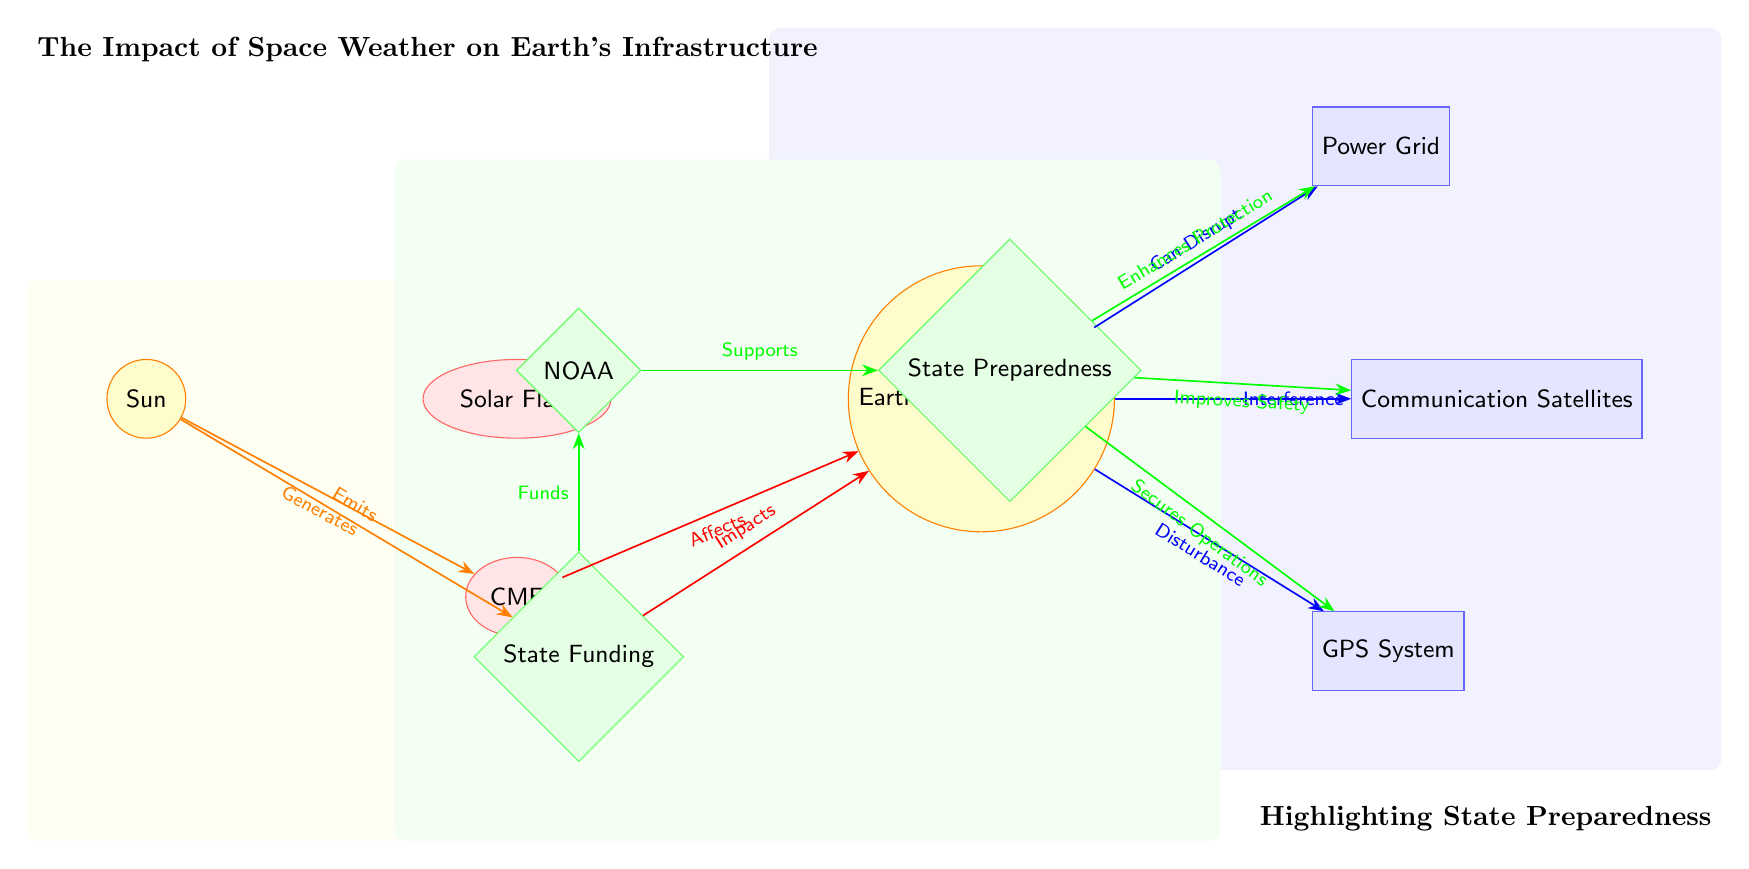What is the primary celestial body shown in the diagram? The diagram identifies the Sun as the primary celestial body, depicted at the top of the structure.
Answer: Sun How many infrastructure elements are represented in the diagram? There are three distinct infrastructure elements: Power Grid, Communication Satellites, and GPS System. This is determined by counting the rectangles colored blue within the infrastructure category.
Answer: 3 What does a Solar Flare impact according to the diagram? The diagram indicates that a Solar Flare impacts Earth's Magnetosphere, which is directly connected by an edge indicating the flow of effect.
Answer: Earth's Magnetosphere Which event is generated by the Sun? According to the diagram, the Sun emits a Solar Flare and generates a Coronal Mass Ejection (CME), both of which are directly shown in relation to the Sun.
Answer: CME What does State Preparedness enhance according to the diagram? The diagram shows that State Preparedness enhances protection for the Power Grid, illustrating the relationship through an edge connecting both nodes.
Answer: Protection How is the GPS System affected by Earth's Magnetosphere? The GPS System is impacted by disturbances, as highlighted in the diagram with an edge indicating disturbance from Earth's Magnetosphere.
Answer: Disturbance What role does NOAA play in the overall diagram? NOAA supports State Preparedness, which is illustrated by an edge running between NOAA and State Preparedness, indicating a supportive relationship.
Answer: Supports What is indicated as a resource that funds NOAA? The diagram specifies that State Funding is a resource that funds NOAA, clearly connected by an edge that points to NOAA from State Funding.
Answer: State Funding What type of event is a CME classified as? In the diagram, a CME is classified as an event, depicted within an ellipse shape and colored red, differentiating it from other elements.
Answer: Event 